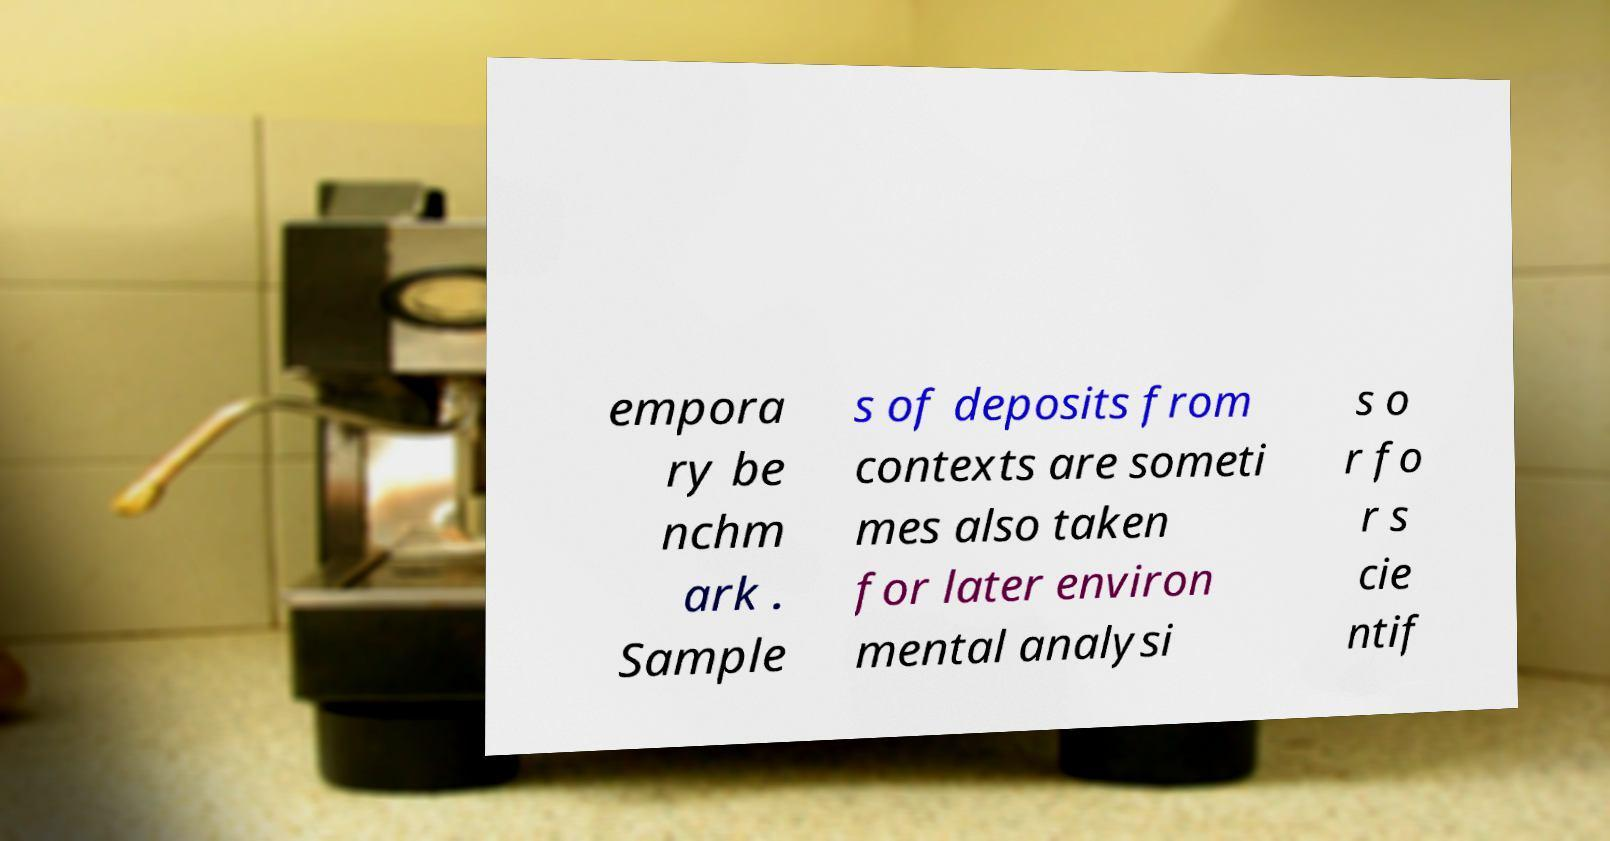Could you extract and type out the text from this image? empora ry be nchm ark . Sample s of deposits from contexts are someti mes also taken for later environ mental analysi s o r fo r s cie ntif 